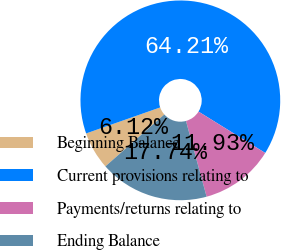Convert chart. <chart><loc_0><loc_0><loc_500><loc_500><pie_chart><fcel>Beginning Balance<fcel>Current provisions relating to<fcel>Payments/returns relating to<fcel>Ending Balance<nl><fcel>6.12%<fcel>64.2%<fcel>11.93%<fcel>17.74%<nl></chart> 